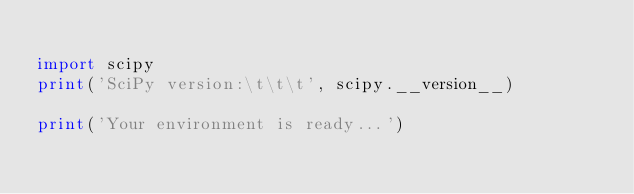<code> <loc_0><loc_0><loc_500><loc_500><_Python_>
import scipy
print('SciPy version:\t\t\t', scipy.__version__)

print('Your environment is ready...')
</code> 